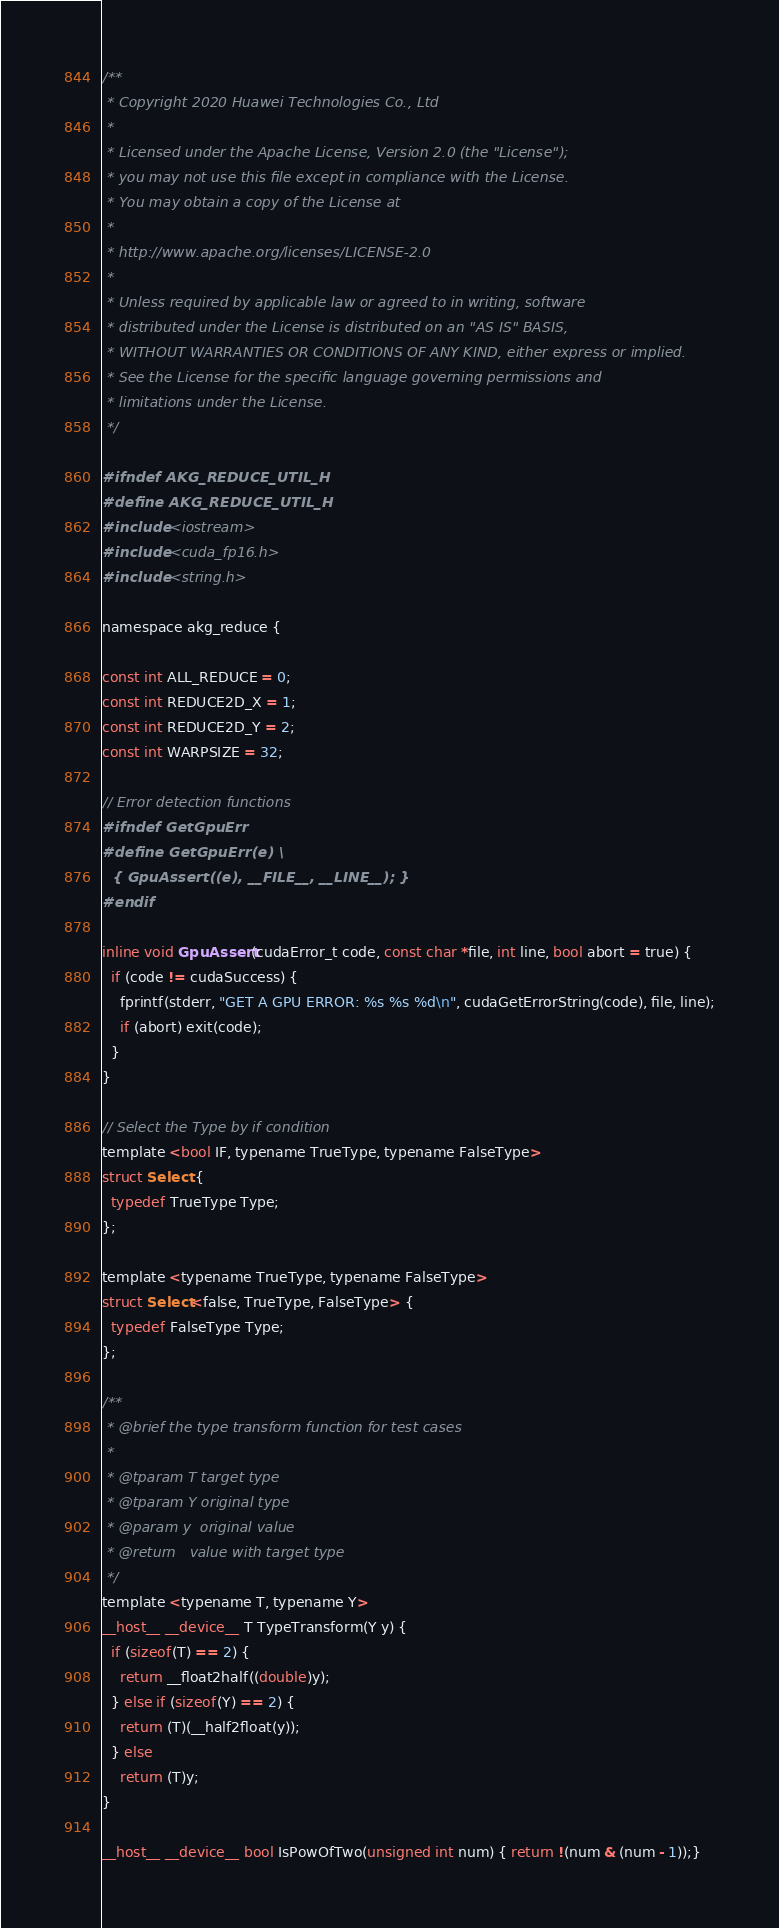<code> <loc_0><loc_0><loc_500><loc_500><_Cuda_>/**
 * Copyright 2020 Huawei Technologies Co., Ltd
 *
 * Licensed under the Apache License, Version 2.0 (the "License");
 * you may not use this file except in compliance with the License.
 * You may obtain a copy of the License at
 *
 * http://www.apache.org/licenses/LICENSE-2.0
 *
 * Unless required by applicable law or agreed to in writing, software
 * distributed under the License is distributed on an "AS IS" BASIS,
 * WITHOUT WARRANTIES OR CONDITIONS OF ANY KIND, either express or implied.
 * See the License for the specific language governing permissions and
 * limitations under the License.
 */

#ifndef AKG_REDUCE_UTIL_H
#define AKG_REDUCE_UTIL_H
#include <iostream>
#include <cuda_fp16.h>
#include <string.h>

namespace akg_reduce {

const int ALL_REDUCE = 0;
const int REDUCE2D_X = 1;
const int REDUCE2D_Y = 2;
const int WARPSIZE = 32;

// Error detection functions
#ifndef GetGpuErr
#define GetGpuErr(e) \
  { GpuAssert((e), __FILE__, __LINE__); }
#endif

inline void GpuAssert(cudaError_t code, const char *file, int line, bool abort = true) {
  if (code != cudaSuccess) {
    fprintf(stderr, "GET A GPU ERROR: %s %s %d\n", cudaGetErrorString(code), file, line);
    if (abort) exit(code);
  }
}

// Select the Type by if condition
template <bool IF, typename TrueType, typename FalseType>
struct Select {
  typedef TrueType Type;
};

template <typename TrueType, typename FalseType>
struct Select<false, TrueType, FalseType> {
  typedef FalseType Type;
};

/**
 * @brief the type transform function for test cases
 * 
 * @tparam T target type
 * @tparam Y original type
 * @param y  original value
 * @return   value with target type
 */
template <typename T, typename Y>
__host__ __device__ T TypeTransform(Y y) {
  if (sizeof(T) == 2) {
    return __float2half((double)y);
  } else if (sizeof(Y) == 2) {
    return (T)(__half2float(y));
  } else
    return (T)y;
}

__host__ __device__ bool IsPowOfTwo(unsigned int num) { return !(num & (num - 1));}
</code> 